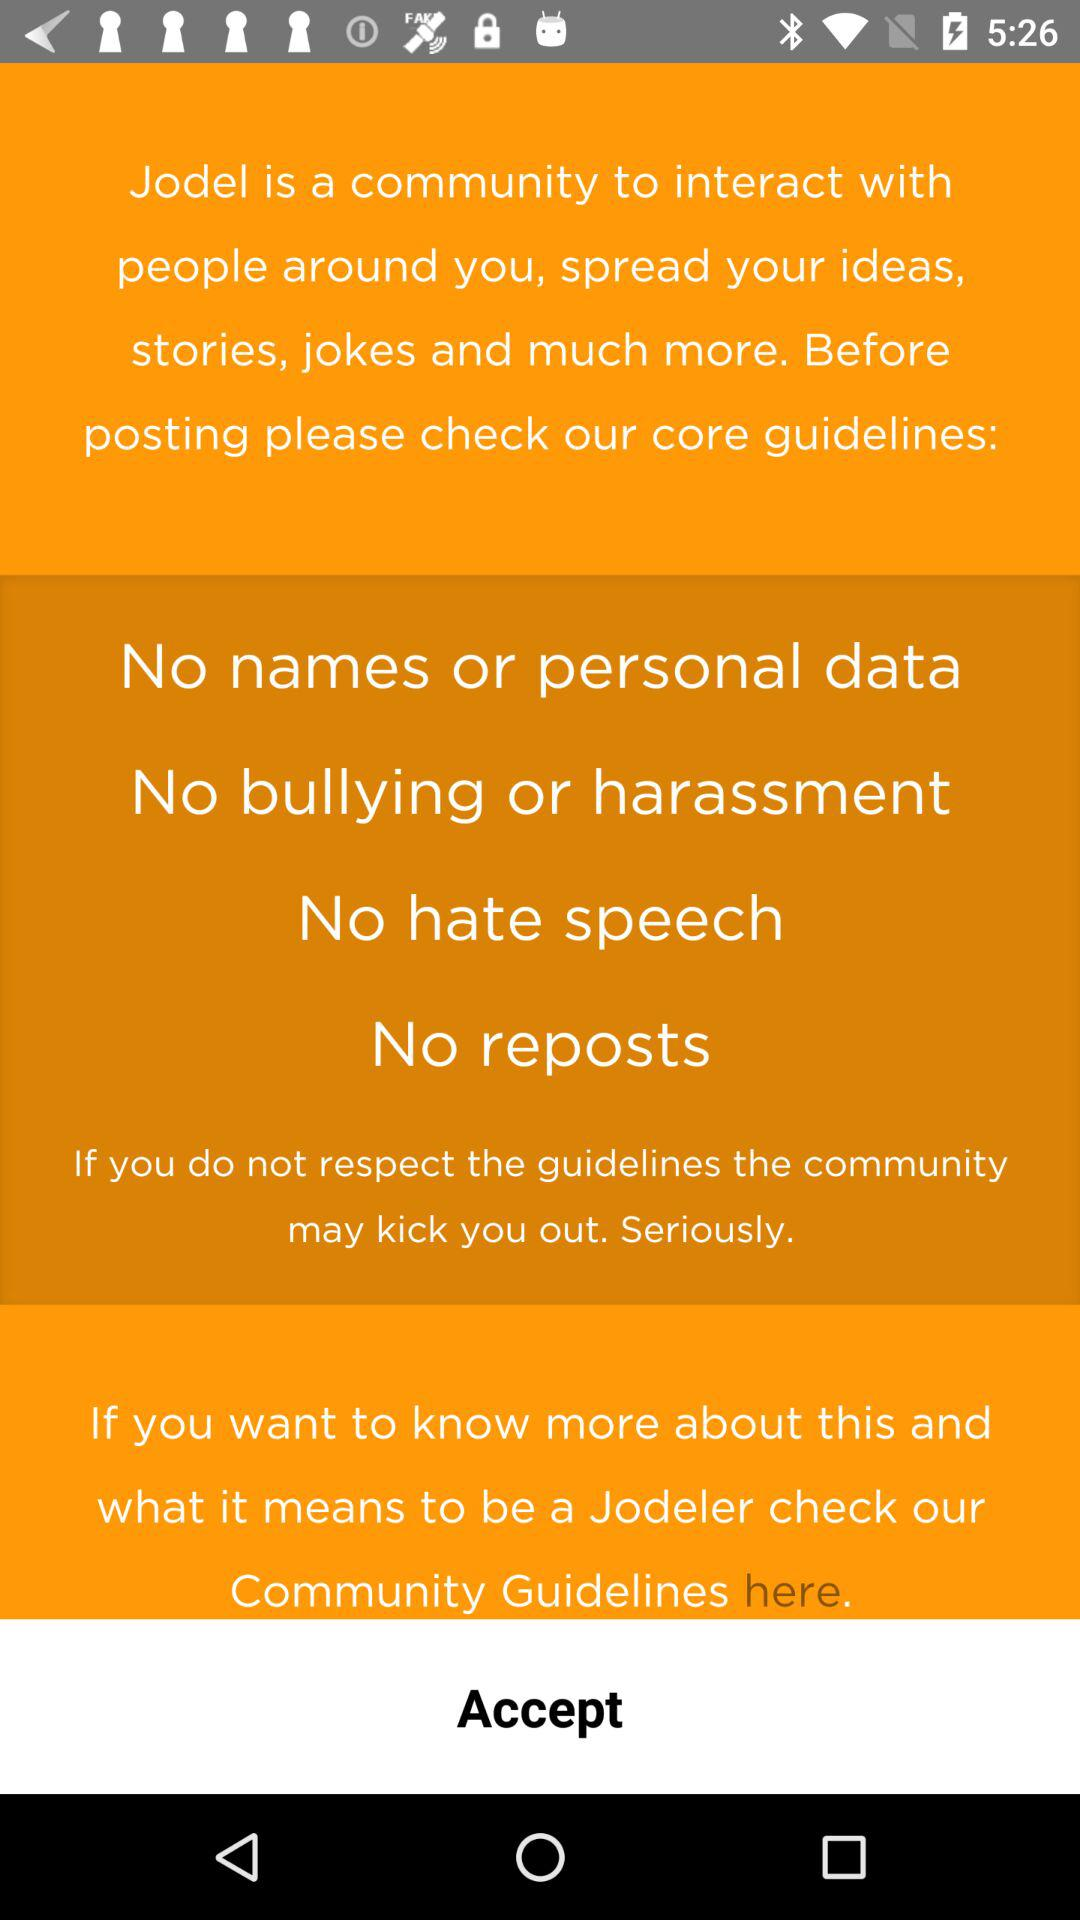How many guidelines are mentioned in the text?
Answer the question using a single word or phrase. 4 